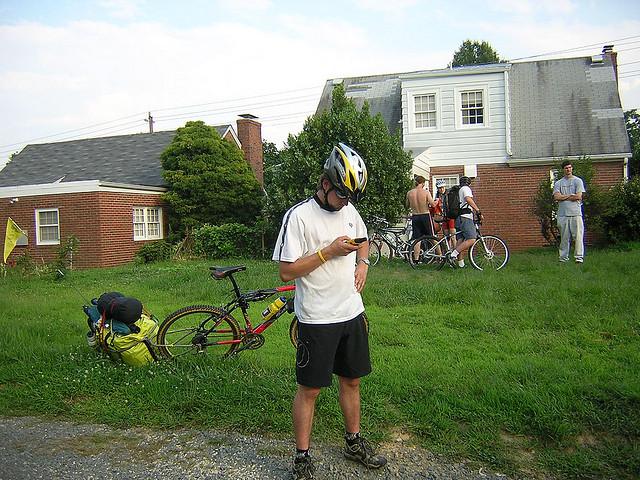Are they all wearing helmets?
Short answer required. No. Is everyone wearing a shirt?
Short answer required. No. Is the man calling someone?
Keep it brief. Yes. 